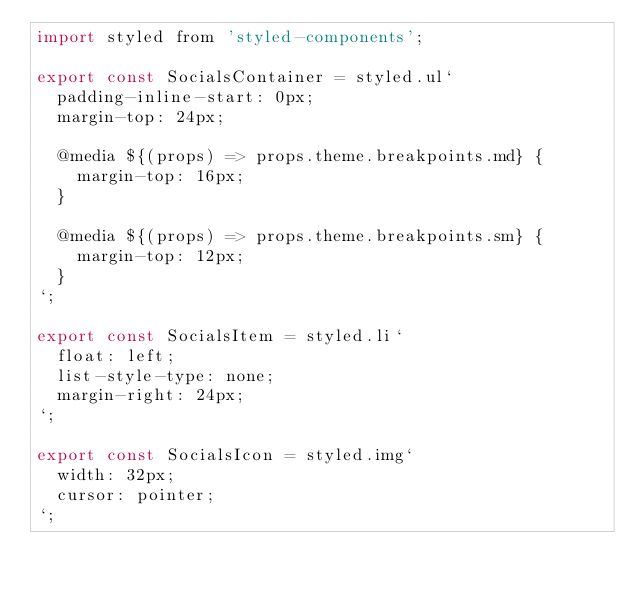Convert code to text. <code><loc_0><loc_0><loc_500><loc_500><_JavaScript_>import styled from 'styled-components';

export const SocialsContainer = styled.ul`
  padding-inline-start: 0px;
  margin-top: 24px;

  @media ${(props) => props.theme.breakpoints.md} {
    margin-top: 16px;
  }

  @media ${(props) => props.theme.breakpoints.sm} {
    margin-top: 12px;
  }
`;

export const SocialsItem = styled.li`
  float: left;
  list-style-type: none;
  margin-right: 24px;
`;

export const SocialsIcon = styled.img`
  width: 32px;
  cursor: pointer;
`;</code> 